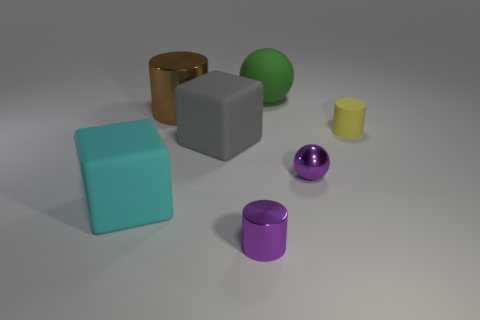Add 2 small purple objects. How many objects exist? 9 Subtract all cubes. How many objects are left? 5 Add 3 small yellow rubber things. How many small yellow rubber things are left? 4 Add 7 yellow rubber objects. How many yellow rubber objects exist? 8 Subtract 0 cyan balls. How many objects are left? 7 Subtract all yellow shiny spheres. Subtract all shiny balls. How many objects are left? 6 